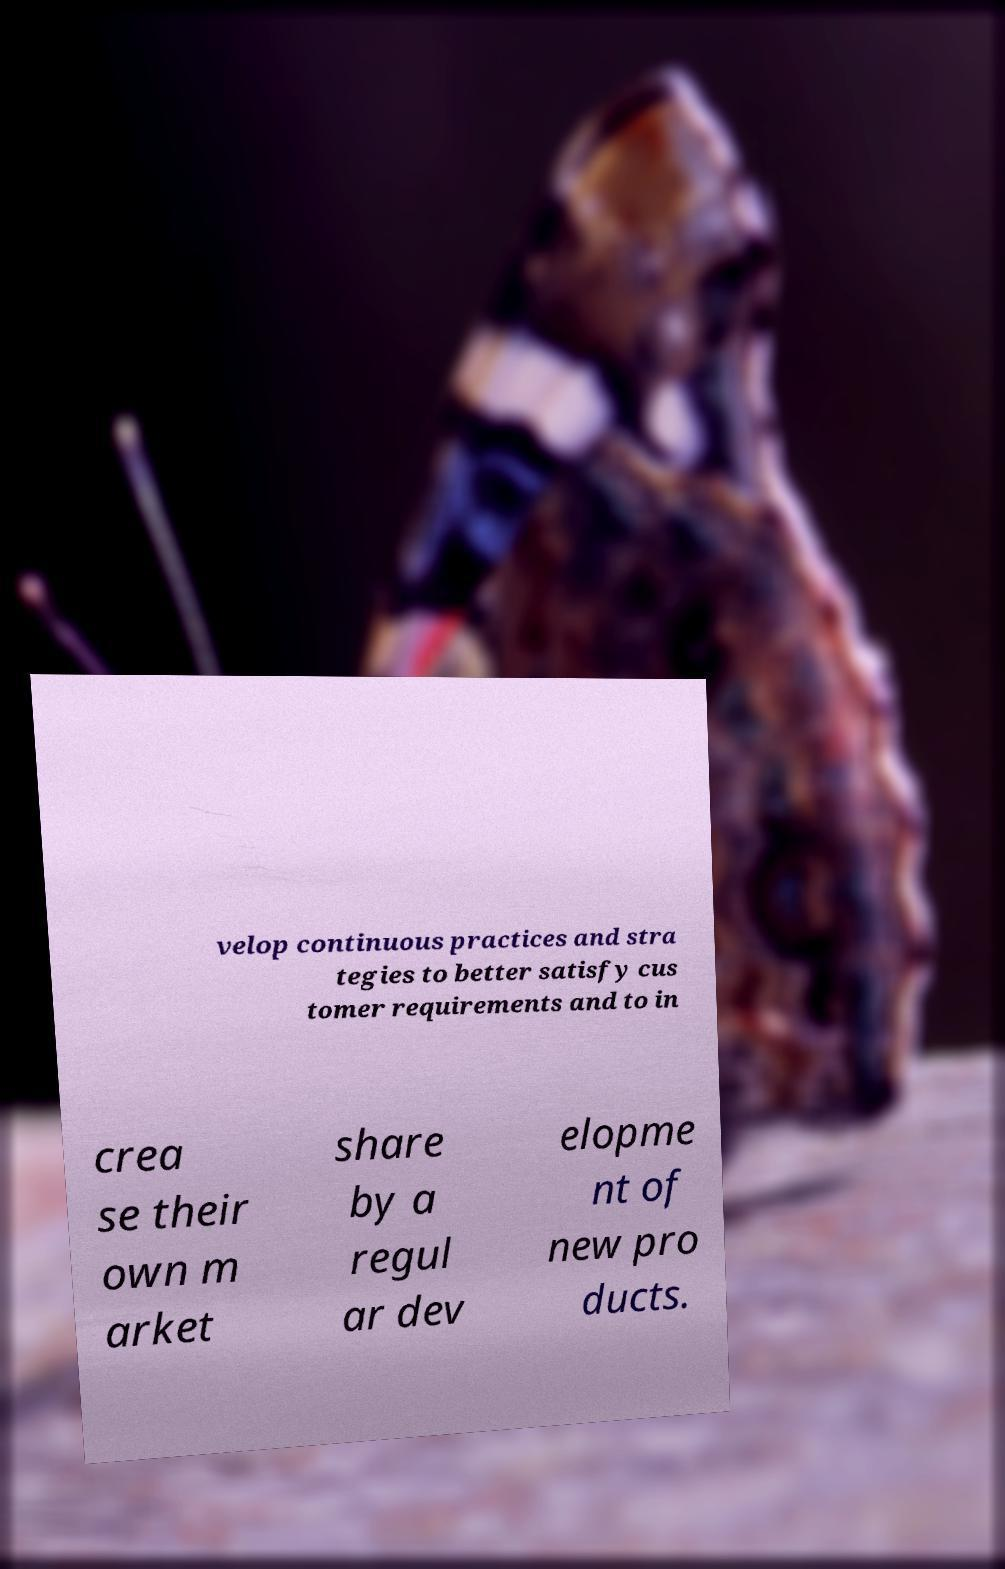For documentation purposes, I need the text within this image transcribed. Could you provide that? velop continuous practices and stra tegies to better satisfy cus tomer requirements and to in crea se their own m arket share by a regul ar dev elopme nt of new pro ducts. 